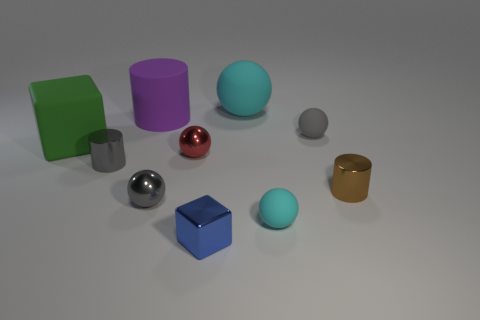Is the shape of the green thing the same as the blue metallic thing?
Give a very brief answer. Yes. Are there an equal number of green matte objects that are on the right side of the purple rubber object and gray cylinders left of the large rubber sphere?
Provide a succinct answer. No. There is another tiny sphere that is made of the same material as the tiny red ball; what color is it?
Your answer should be compact. Gray. How many other green things have the same material as the large green object?
Provide a short and direct response. 0. There is a tiny metal cylinder left of the big cyan rubber sphere; is its color the same as the large cube?
Your response must be concise. No. How many blue objects have the same shape as the big green matte thing?
Make the answer very short. 1. Are there an equal number of tiny cyan balls in front of the small metallic cube and small yellow matte things?
Make the answer very short. Yes. The block that is the same size as the gray cylinder is what color?
Your response must be concise. Blue. Is there a big yellow shiny object of the same shape as the large purple rubber object?
Provide a short and direct response. No. What material is the cyan object in front of the gray sphere that is to the left of the cyan rubber sphere in front of the big green matte object?
Provide a short and direct response. Rubber. 